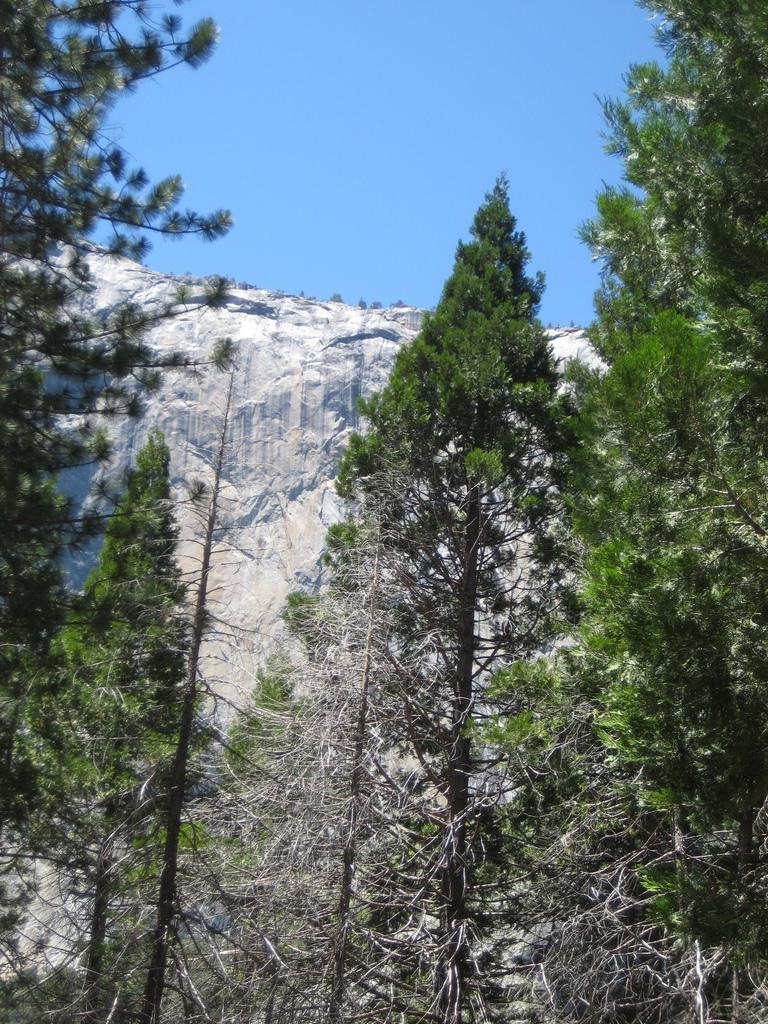What type of vegetation is present in the image? There are green trees in the image. What geographical feature can be seen in the image? There is a mountain in the image. What color is the sky at the top of the image? The sky is blue at the top of the image. Can you tell me how many coaches are parked in the room in the image? There are no coaches or rooms present in the image; it features green trees, a mountain, and a blue sky. What type of creature is shown pushing the mountain in the image? There is no creature shown pushing the mountain in the image; the mountain is stationary. 